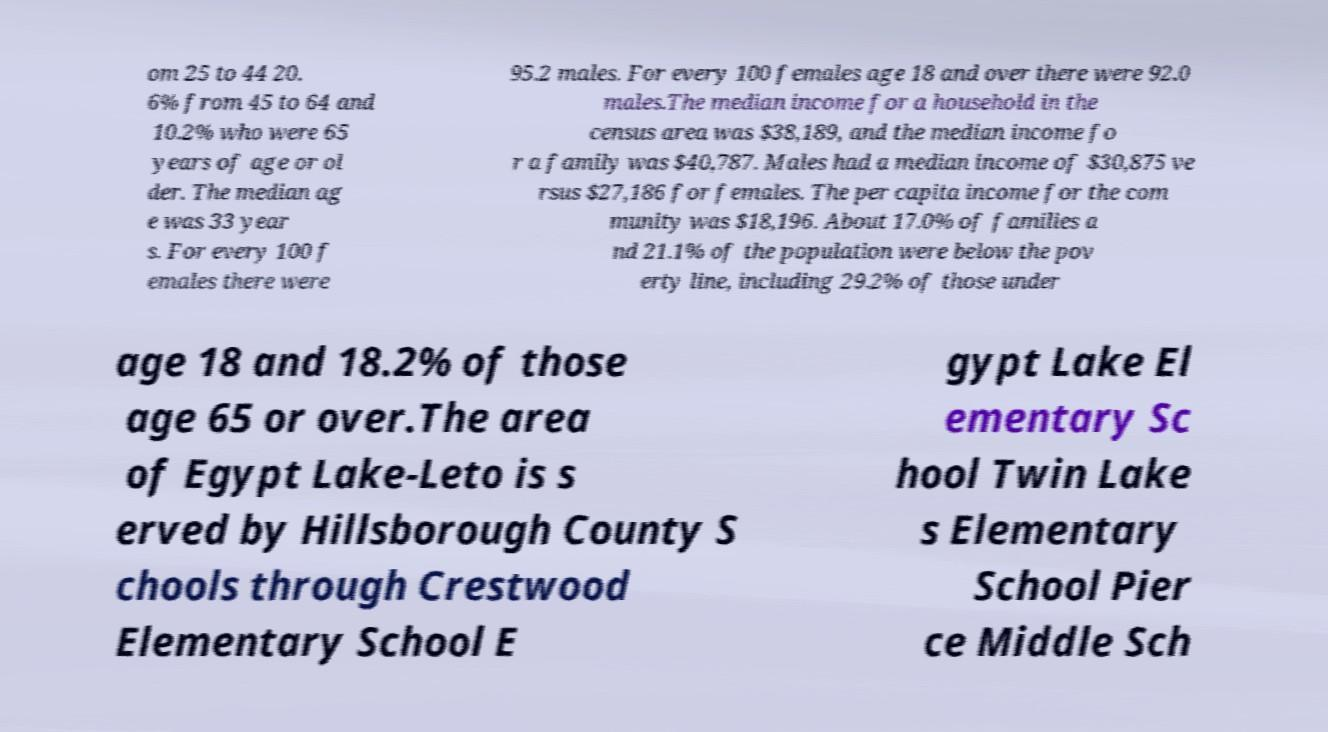Please read and relay the text visible in this image. What does it say? om 25 to 44 20. 6% from 45 to 64 and 10.2% who were 65 years of age or ol der. The median ag e was 33 year s. For every 100 f emales there were 95.2 males. For every 100 females age 18 and over there were 92.0 males.The median income for a household in the census area was $38,189, and the median income fo r a family was $40,787. Males had a median income of $30,875 ve rsus $27,186 for females. The per capita income for the com munity was $18,196. About 17.0% of families a nd 21.1% of the population were below the pov erty line, including 29.2% of those under age 18 and 18.2% of those age 65 or over.The area of Egypt Lake-Leto is s erved by Hillsborough County S chools through Crestwood Elementary School E gypt Lake El ementary Sc hool Twin Lake s Elementary School Pier ce Middle Sch 